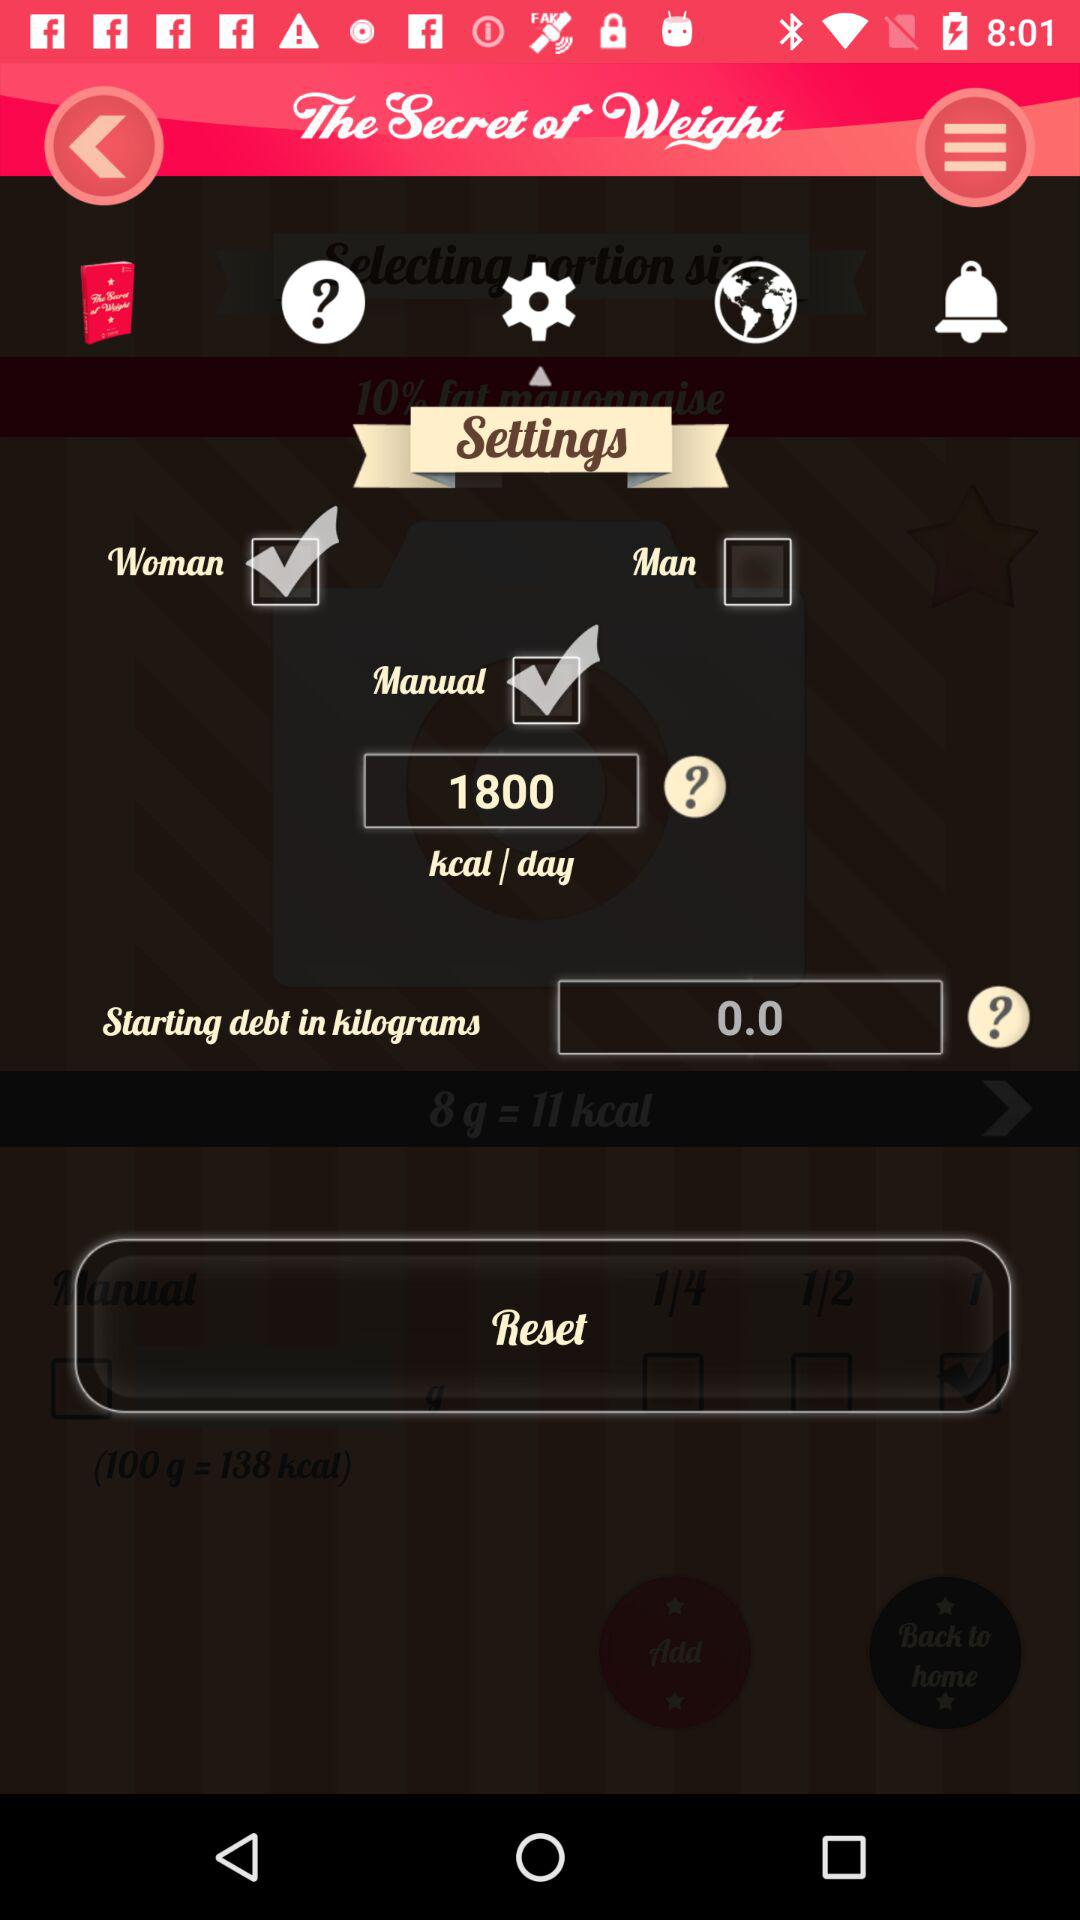What is the status of "Manual"? The status of "Manual" is "on". 